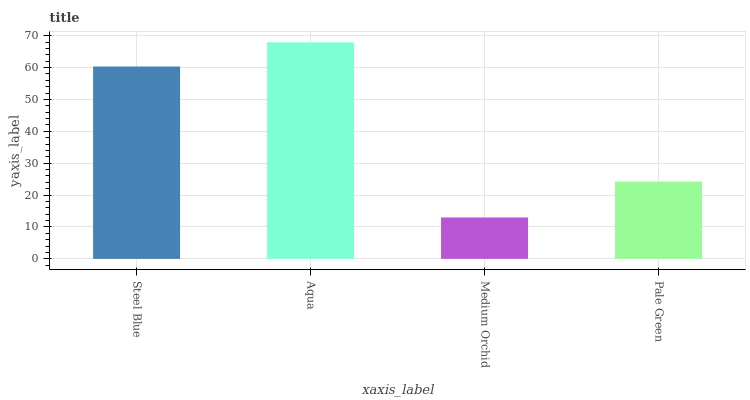Is Medium Orchid the minimum?
Answer yes or no. Yes. Is Aqua the maximum?
Answer yes or no. Yes. Is Aqua the minimum?
Answer yes or no. No. Is Medium Orchid the maximum?
Answer yes or no. No. Is Aqua greater than Medium Orchid?
Answer yes or no. Yes. Is Medium Orchid less than Aqua?
Answer yes or no. Yes. Is Medium Orchid greater than Aqua?
Answer yes or no. No. Is Aqua less than Medium Orchid?
Answer yes or no. No. Is Steel Blue the high median?
Answer yes or no. Yes. Is Pale Green the low median?
Answer yes or no. Yes. Is Pale Green the high median?
Answer yes or no. No. Is Medium Orchid the low median?
Answer yes or no. No. 